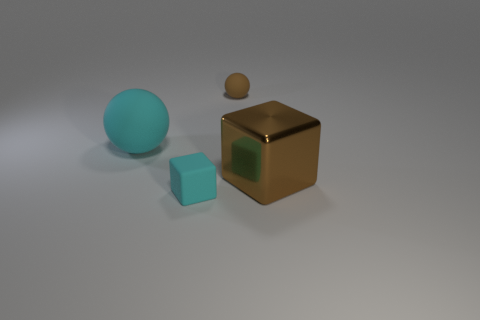Add 3 tiny brown balls. How many objects exist? 7 Subtract 1 cubes. How many cubes are left? 1 Subtract all brown cubes. Subtract all cyan cylinders. How many cubes are left? 1 Subtract all purple spheres. How many cyan blocks are left? 1 Subtract all tiny things. Subtract all brown objects. How many objects are left? 0 Add 2 big brown metal cubes. How many big brown metal cubes are left? 3 Add 1 big purple metallic blocks. How many big purple metallic blocks exist? 1 Subtract 0 blue blocks. How many objects are left? 4 